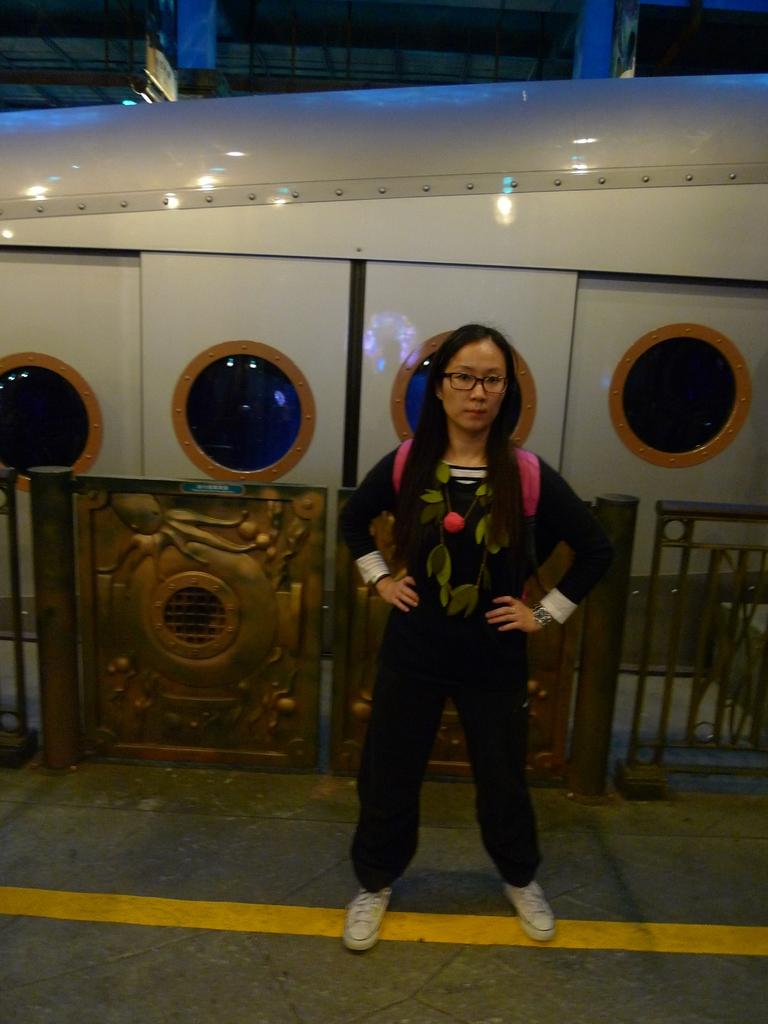What is the main subject of the image? The main subject of the image is a lady. What accessories is the lady wearing? The lady is wearing specs, a bag, and a watch. What is the lady's posture in the image? The lady is standing in the image. What can be seen in the background of the image? There is a railing with doors and a train in the background. What type of structure is visible in the background? There are railings in the background. What type of roof can be seen above the lady in the image? There is no roof visible above the lady in the image. How many bulbs are hanging from the railing in the background? There are no bulbs present in the image. 